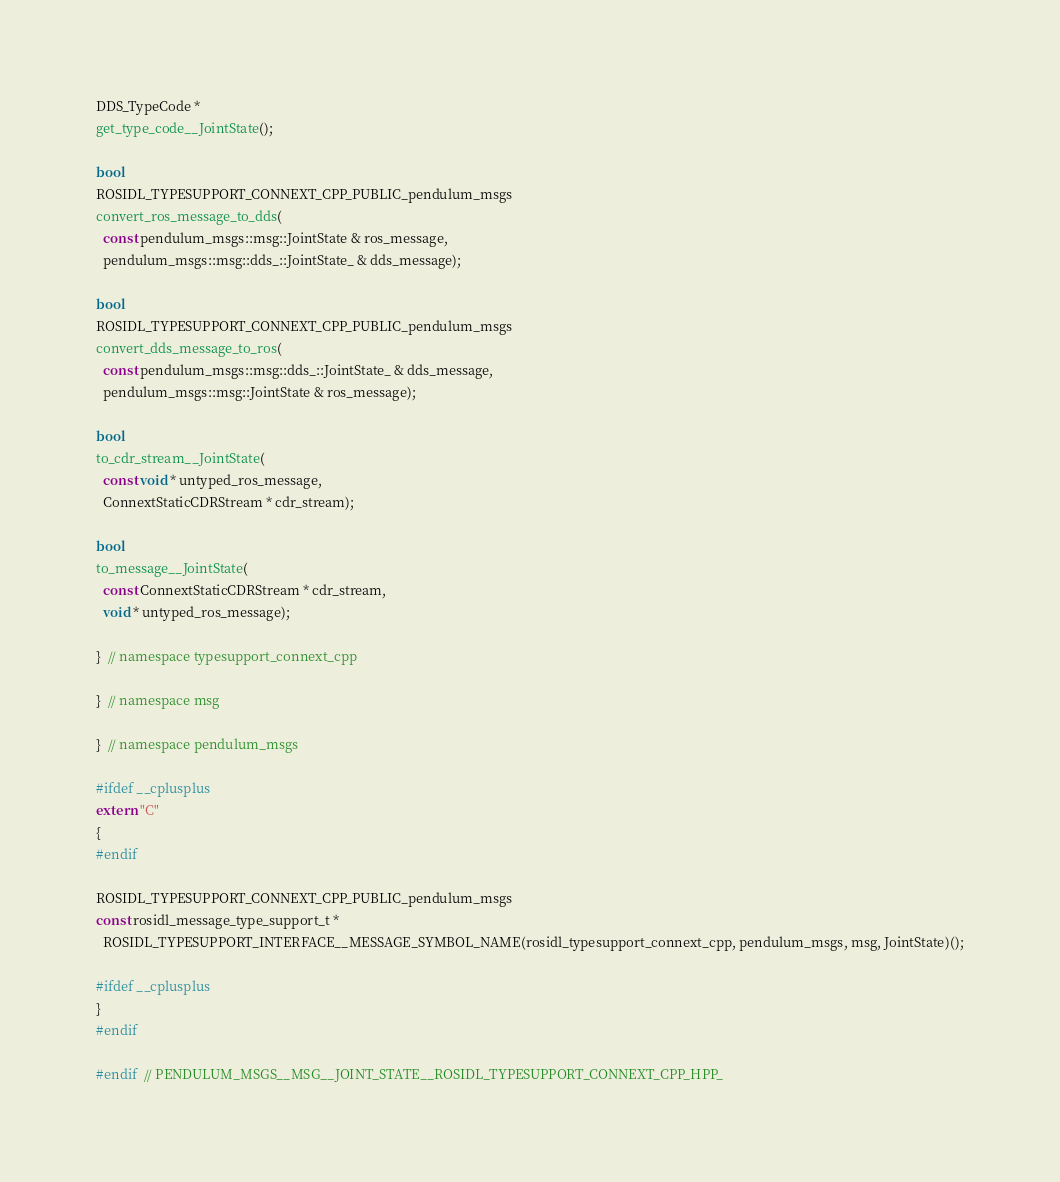<code> <loc_0><loc_0><loc_500><loc_500><_C++_>DDS_TypeCode *
get_type_code__JointState();

bool
ROSIDL_TYPESUPPORT_CONNEXT_CPP_PUBLIC_pendulum_msgs
convert_ros_message_to_dds(
  const pendulum_msgs::msg::JointState & ros_message,
  pendulum_msgs::msg::dds_::JointState_ & dds_message);

bool
ROSIDL_TYPESUPPORT_CONNEXT_CPP_PUBLIC_pendulum_msgs
convert_dds_message_to_ros(
  const pendulum_msgs::msg::dds_::JointState_ & dds_message,
  pendulum_msgs::msg::JointState & ros_message);

bool
to_cdr_stream__JointState(
  const void * untyped_ros_message,
  ConnextStaticCDRStream * cdr_stream);

bool
to_message__JointState(
  const ConnextStaticCDRStream * cdr_stream,
  void * untyped_ros_message);

}  // namespace typesupport_connext_cpp

}  // namespace msg

}  // namespace pendulum_msgs

#ifdef __cplusplus
extern "C"
{
#endif

ROSIDL_TYPESUPPORT_CONNEXT_CPP_PUBLIC_pendulum_msgs
const rosidl_message_type_support_t *
  ROSIDL_TYPESUPPORT_INTERFACE__MESSAGE_SYMBOL_NAME(rosidl_typesupport_connext_cpp, pendulum_msgs, msg, JointState)();

#ifdef __cplusplus
}
#endif

#endif  // PENDULUM_MSGS__MSG__JOINT_STATE__ROSIDL_TYPESUPPORT_CONNEXT_CPP_HPP_
</code> 